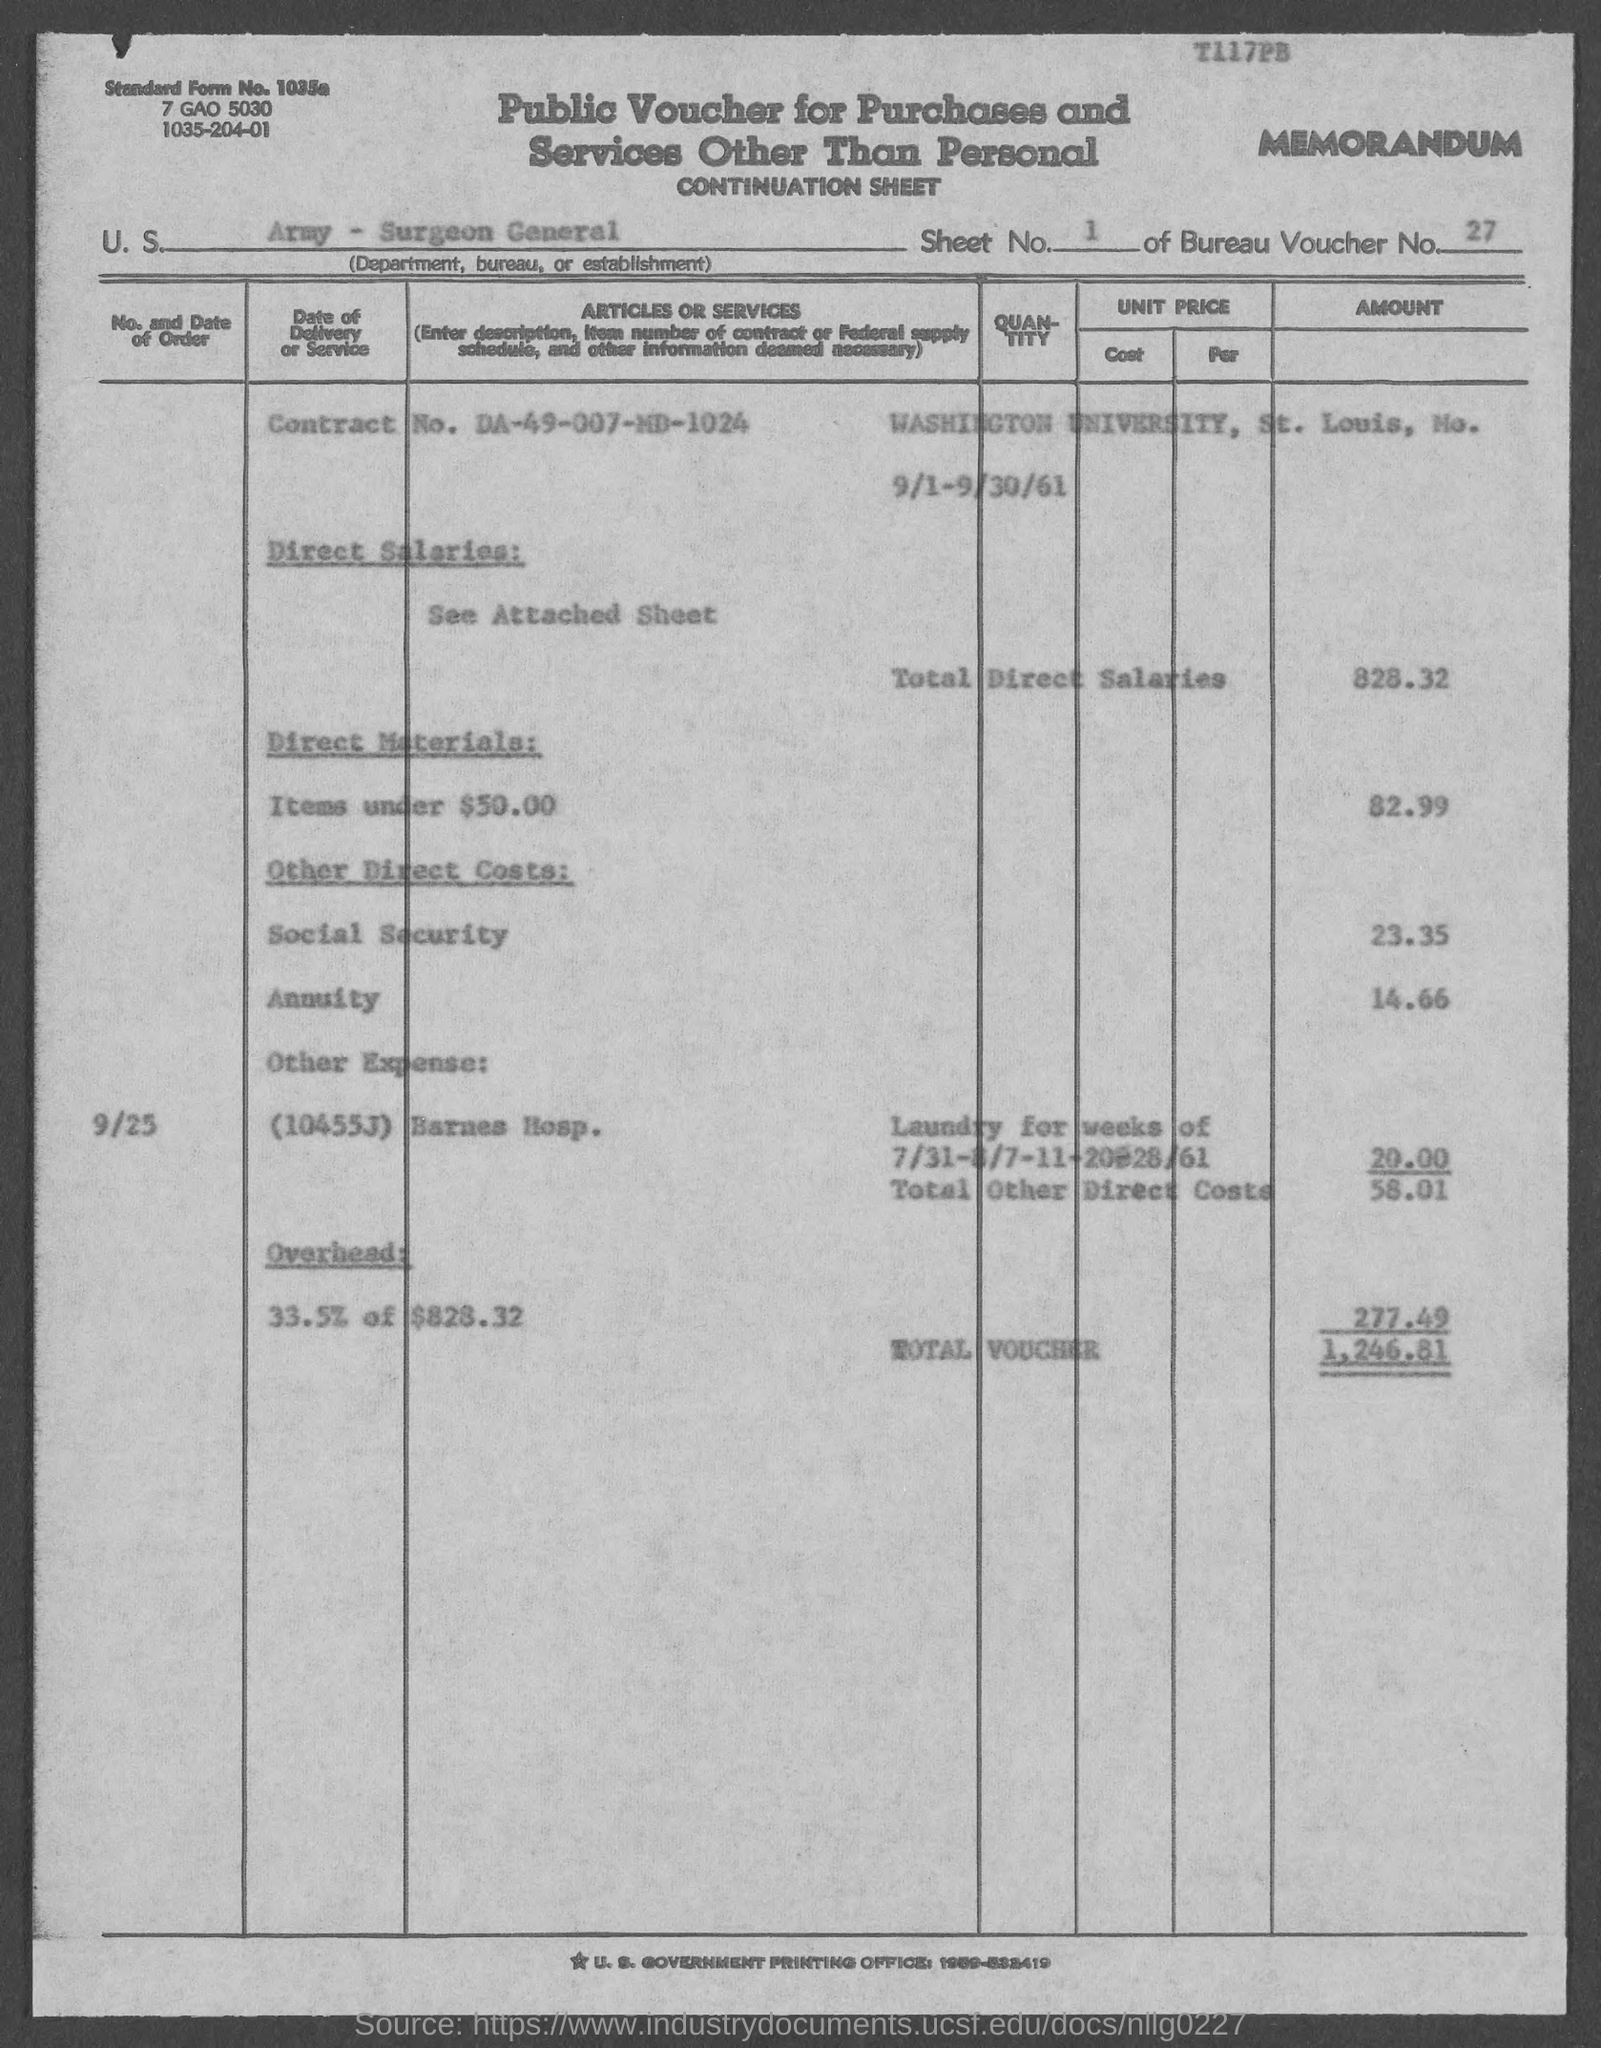What is the standard form no.?
Provide a succinct answer. 1035a. What is the sheet no.?
Provide a succinct answer. 1. What is the voucher no.?
Your answer should be compact. 27. What is the contract no.?
Make the answer very short. DA-49-007-MD-1024. In which city is washington university at ?
Offer a terse response. St. Louis. What is total voucher ?
Ensure brevity in your answer.  1,246.81. What is the total direct salaries ?
Make the answer very short. 828.32. What is total other direct costs ?
Provide a short and direct response. 58.01. 